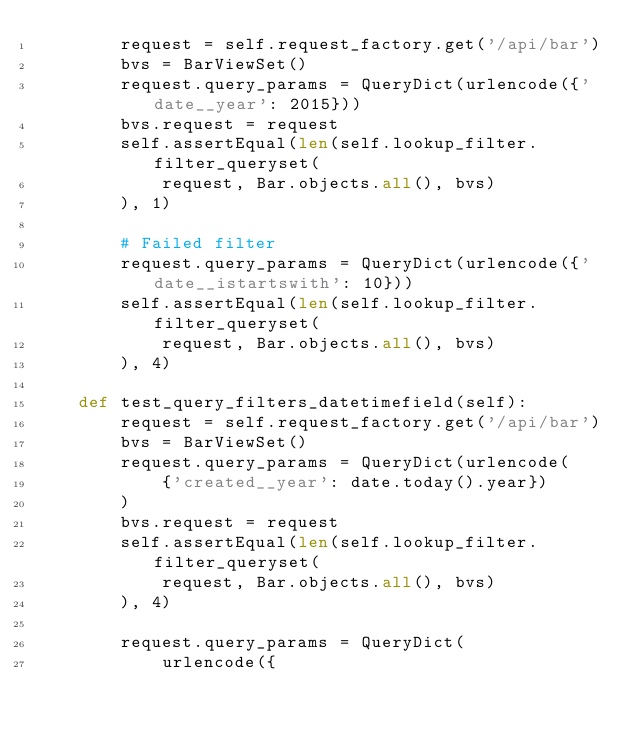<code> <loc_0><loc_0><loc_500><loc_500><_Python_>        request = self.request_factory.get('/api/bar')
        bvs = BarViewSet()
        request.query_params = QueryDict(urlencode({'date__year': 2015}))
        bvs.request = request
        self.assertEqual(len(self.lookup_filter.filter_queryset(
            request, Bar.objects.all(), bvs)
        ), 1)

        # Failed filter
        request.query_params = QueryDict(urlencode({'date__istartswith': 10}))
        self.assertEqual(len(self.lookup_filter.filter_queryset(
            request, Bar.objects.all(), bvs)
        ), 4)

    def test_query_filters_datetimefield(self):
        request = self.request_factory.get('/api/bar')
        bvs = BarViewSet()
        request.query_params = QueryDict(urlencode(
            {'created__year': date.today().year})
        )
        bvs.request = request
        self.assertEqual(len(self.lookup_filter.filter_queryset(
            request, Bar.objects.all(), bvs)
        ), 4)

        request.query_params = QueryDict(
            urlencode({</code> 